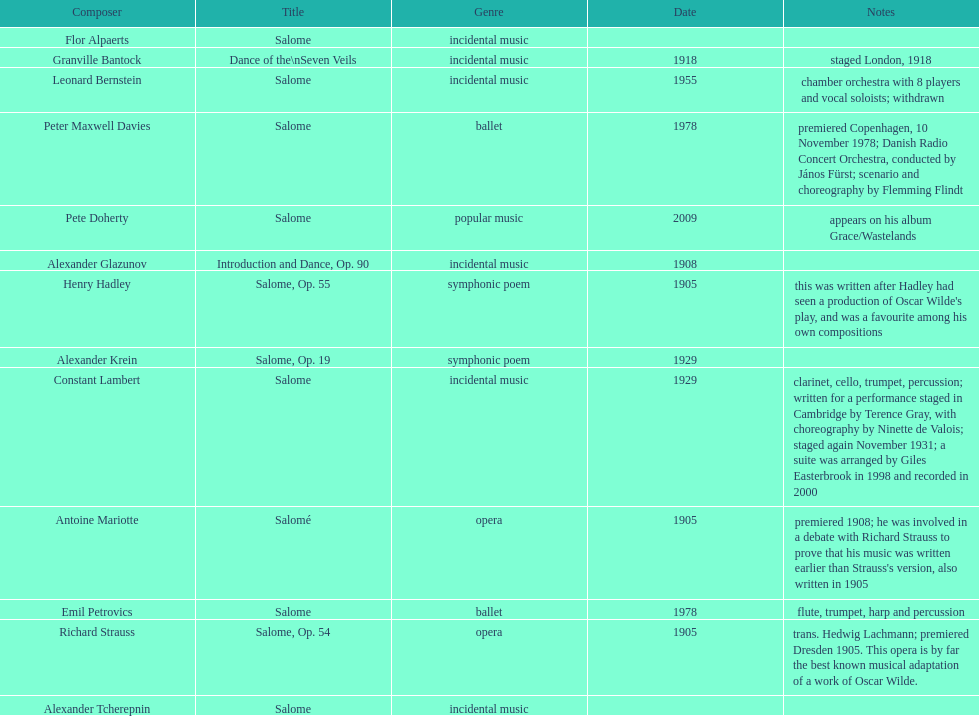Who is ranked number one on the list? Flor Alpaerts. 